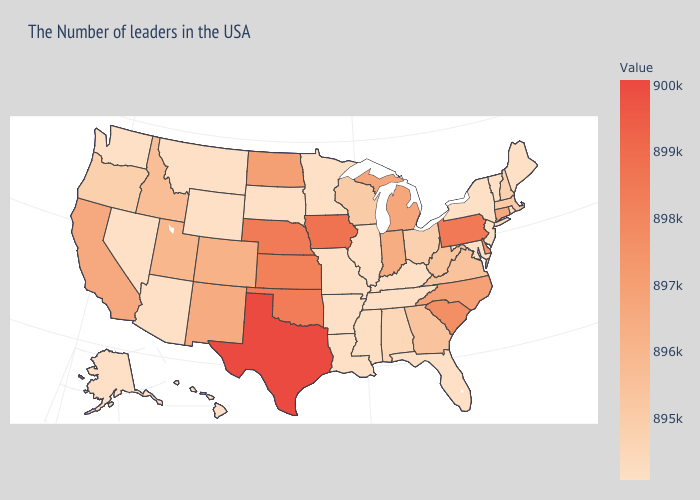Does Wyoming have the highest value in the West?
Short answer required. No. Which states have the lowest value in the Northeast?
Keep it brief. Maine, Rhode Island, Vermont, New York, New Jersey. Does Alabama have the lowest value in the USA?
Write a very short answer. No. Which states have the lowest value in the Northeast?
Quick response, please. Maine, Rhode Island, Vermont, New York, New Jersey. Is the legend a continuous bar?
Quick response, please. Yes. Among the states that border Missouri , which have the highest value?
Be succinct. Iowa. 